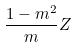<formula> <loc_0><loc_0><loc_500><loc_500>\frac { 1 - m ^ { 2 } } { m } Z</formula> 